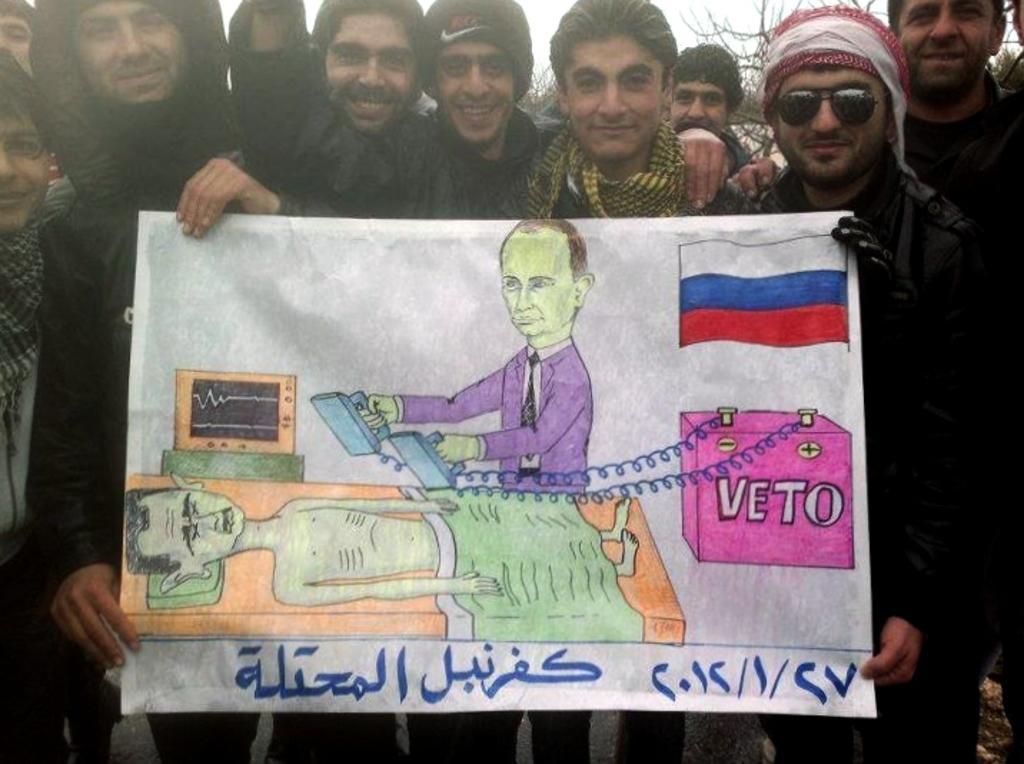Please provide a concise description of this image. In this picture I can see group of people standing and smiling by holding a paper, and in the background there are trees and sky. 